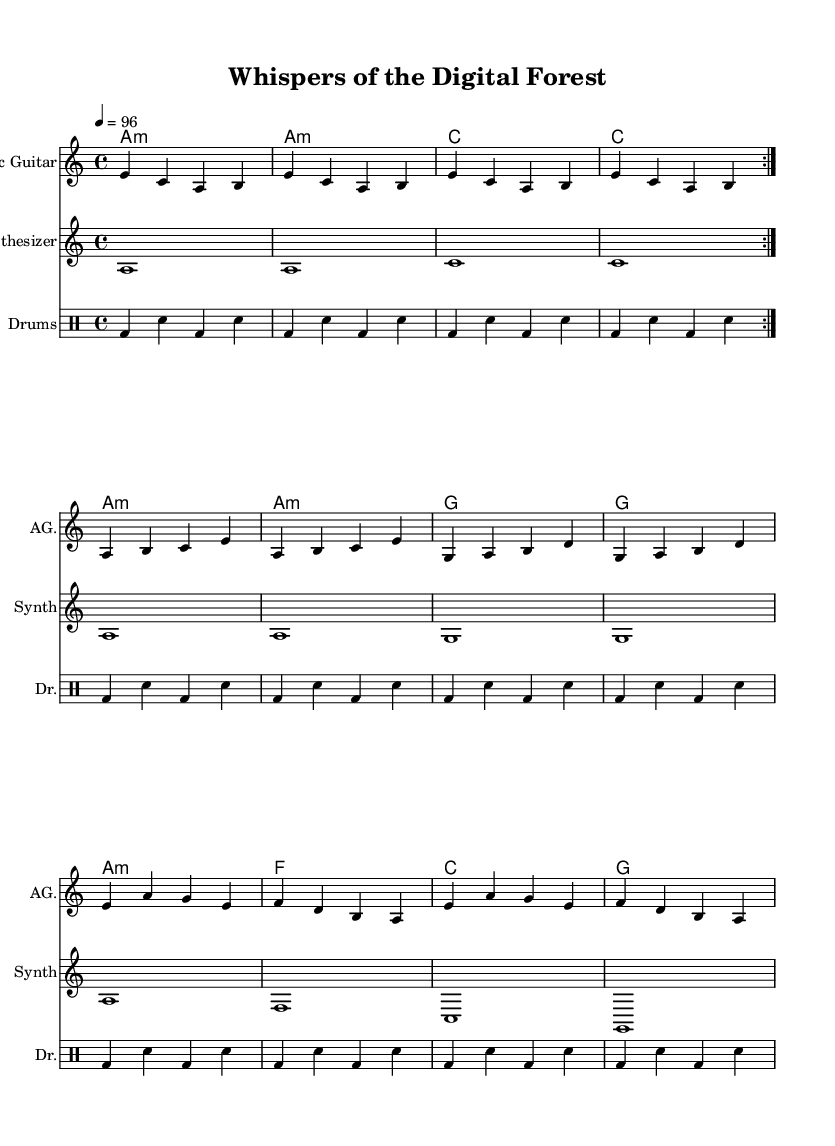What is the key signature of this music? The key signature is indicated at the beginning of the sheet music, and it shows that there is one flat, corresponding to the key of A minor.
Answer: A minor What is the time signature? The time signature is noted at the start of the score, showing there are four beats per measure, which is indicated as a 4/4 time signature.
Answer: 4/4 What is the tempo marking? The tempo marking indicates the speed of the piece, found at the beginning and specified as a quarter note equals 96 beats per minute.
Answer: 96 How many measures are in the acoustic guitar part? The acoustic guitar part includes several repetitions, and by counting the measures, we can identify that there are 16 measures total in the piece.
Answer: 16 What instrument plays the synthesizer part? The synthesizer part is performed on the second staff of the score, where it is clearly labeled as "Synth" at the top.
Answer: Synth How are the chords structured in the guitar part? The guitar part shows a chord progression that consists of several measures of A minor and C major, showcasing a typical electronic sound structure with a repetitive pattern.
Answer: A minor, C major What kind of rhythm does the drum part use? The rhythm in the drum part is a repetitive pattern primarily comprising bass drum and snare drum hits, which creates a driving beat suitable for electronic music.
Answer: Driving beat 